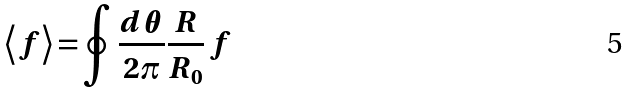Convert formula to latex. <formula><loc_0><loc_0><loc_500><loc_500>\left \langle f \right \rangle = \oint \frac { d \theta } { 2 \pi } \frac { R } { R _ { 0 } } \, f</formula> 